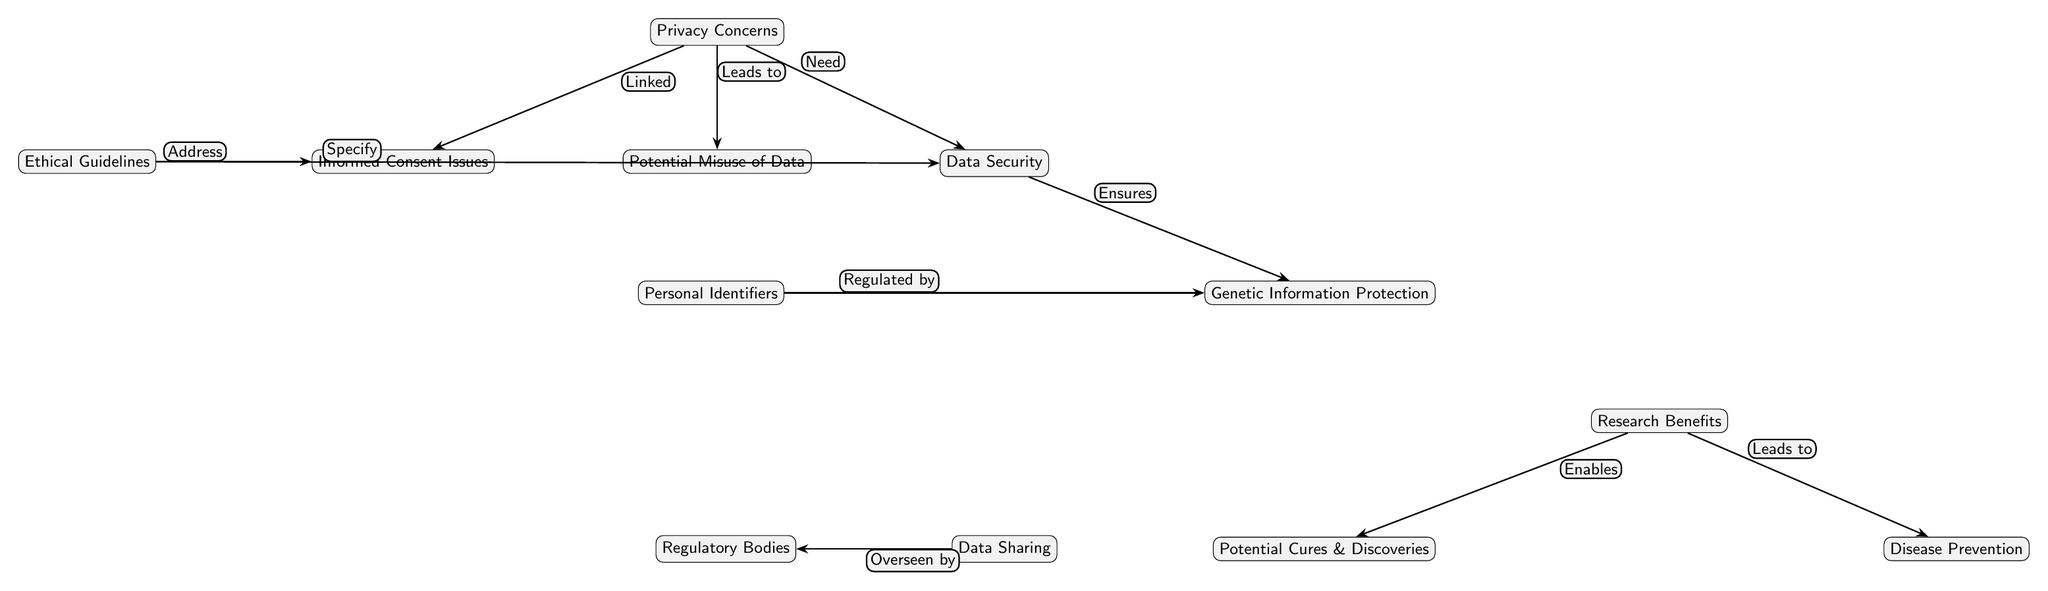What is the main focus of the diagram? The diagram primarily focuses on the "Privacy Concerns" related to biomedical data collection. It serves as the central node from which various other concerns and benefits radiate.
Answer: Privacy Concerns How many total nodes are present in the diagram? By counting every individual item in the diagram, we find that there are a total of 12 nodes, including the central node.
Answer: 12 What does "Ethical Guidelines" address? The "Ethical Guidelines" node connects to the "Informed Consent Issues," indicating a direct relationship where ethical guidelines specifically aim to address these concerns.
Answer: Informed Consent Issues What does "Data Security" ensure? The "Data Security" is directed towards ensuring "Genetic Information Protection," showing a vital role in safeguarding sensitive information collected in genomic studies.
Answer: Genetic Information Protection How many edges are connecting to "Privacy Concerns"? The "Privacy Concerns" node has three edges connected to "Informed Consent Issues," "Data Security," and "Potential Misuse of Data," establishing multiple links directly associating various issues with privacy.
Answer: 3 What leads to "Potential Misuse of Data"? The relationship defined in the diagram indicates that "Privacy Concerns" leads to the "Potential Misuse of Data," suggesting that concerns regarding privacy can result in misuse.
Answer: Privacy Concerns Which two benefits are enabled by "Research Benefits"? The node "Research Benefits" connects to two specific outcomes: "Potential Cures & Discoveries" and "Disease Prevention," outlining the potential benefits of genomic studies.
Answer: Potential Cures & Discoveries, Disease Prevention What is regulated by "Personal Identifiers"? According to the diagram, "Personal Identifiers" is regulated by "Genetic Information Protection," illustrating the regulatory framework surrounding sensitive data.
Answer: Genetic Information Protection Who oversees "Data Sharing"? The "Data Sharing" node is overseen by "Regulatory Bodies," indicating the role of governance in managing data sharing practices in genomic studies.
Answer: Regulatory Bodies 